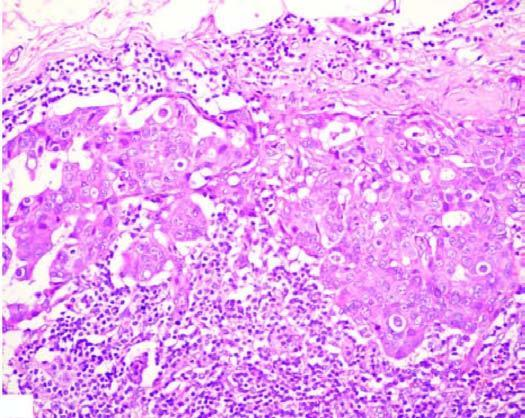what is matted mass of lymph nodes surrounded by?
Answer the question using a single word or phrase. Increased fat 